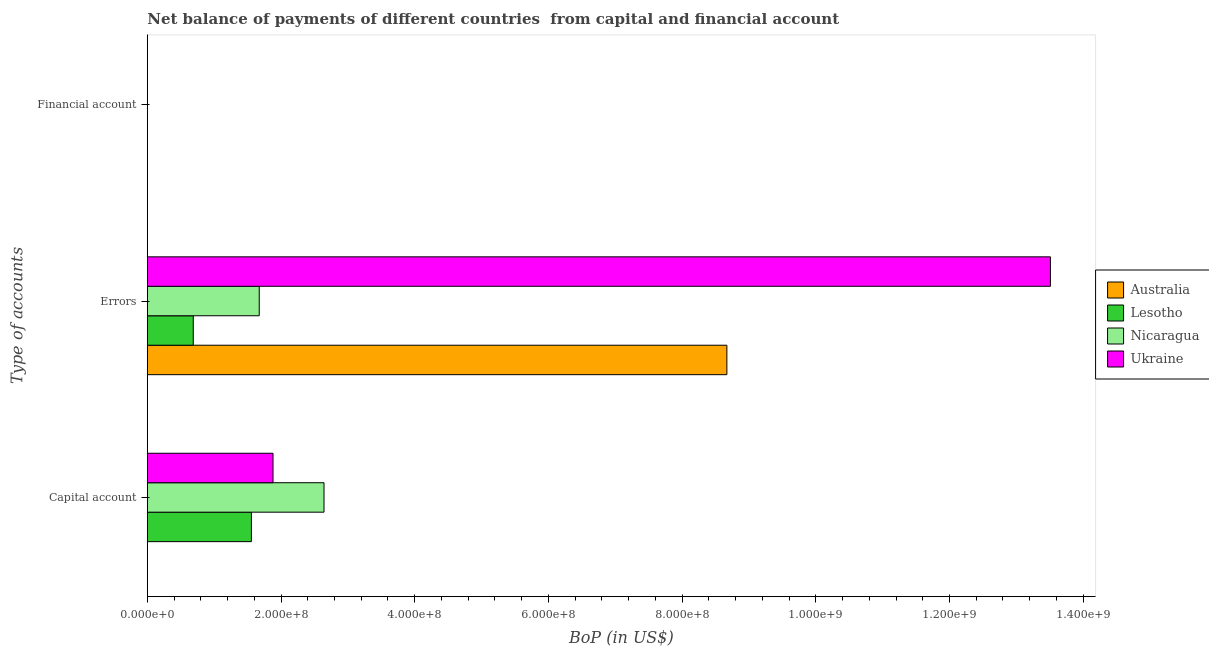Are the number of bars per tick equal to the number of legend labels?
Provide a short and direct response. No. Are the number of bars on each tick of the Y-axis equal?
Give a very brief answer. No. What is the label of the 3rd group of bars from the top?
Offer a terse response. Capital account. What is the amount of errors in Ukraine?
Provide a succinct answer. 1.35e+09. Across all countries, what is the maximum amount of errors?
Provide a succinct answer. 1.35e+09. Across all countries, what is the minimum amount of net capital account?
Your answer should be compact. 0. In which country was the amount of net capital account maximum?
Your answer should be very brief. Nicaragua. What is the total amount of financial account in the graph?
Your response must be concise. 0. What is the difference between the amount of errors in Australia and that in Lesotho?
Your answer should be very brief. 7.98e+08. What is the difference between the amount of errors in Australia and the amount of net capital account in Ukraine?
Provide a succinct answer. 6.79e+08. What is the average amount of errors per country?
Your answer should be very brief. 6.14e+08. What is the difference between the amount of errors and amount of net capital account in Lesotho?
Make the answer very short. -8.70e+07. In how many countries, is the amount of net capital account greater than 1280000000 US$?
Ensure brevity in your answer.  0. What is the ratio of the amount of errors in Australia to that in Ukraine?
Your answer should be very brief. 0.64. What is the difference between the highest and the second highest amount of errors?
Ensure brevity in your answer.  4.84e+08. What is the difference between the highest and the lowest amount of errors?
Ensure brevity in your answer.  1.28e+09. In how many countries, is the amount of financial account greater than the average amount of financial account taken over all countries?
Make the answer very short. 0. Is it the case that in every country, the sum of the amount of net capital account and amount of errors is greater than the amount of financial account?
Make the answer very short. Yes. How many bars are there?
Provide a succinct answer. 7. What is the difference between two consecutive major ticks on the X-axis?
Keep it short and to the point. 2.00e+08. Are the values on the major ticks of X-axis written in scientific E-notation?
Your response must be concise. Yes. Does the graph contain any zero values?
Your answer should be compact. Yes. Where does the legend appear in the graph?
Make the answer very short. Center right. How many legend labels are there?
Provide a short and direct response. 4. How are the legend labels stacked?
Provide a succinct answer. Vertical. What is the title of the graph?
Your answer should be compact. Net balance of payments of different countries  from capital and financial account. What is the label or title of the X-axis?
Make the answer very short. BoP (in US$). What is the label or title of the Y-axis?
Provide a succinct answer. Type of accounts. What is the BoP (in US$) in Lesotho in Capital account?
Ensure brevity in your answer.  1.56e+08. What is the BoP (in US$) in Nicaragua in Capital account?
Your response must be concise. 2.64e+08. What is the BoP (in US$) of Ukraine in Capital account?
Your answer should be compact. 1.88e+08. What is the BoP (in US$) in Australia in Errors?
Your answer should be very brief. 8.67e+08. What is the BoP (in US$) in Lesotho in Errors?
Offer a terse response. 6.87e+07. What is the BoP (in US$) of Nicaragua in Errors?
Make the answer very short. 1.67e+08. What is the BoP (in US$) in Ukraine in Errors?
Ensure brevity in your answer.  1.35e+09. What is the BoP (in US$) in Australia in Financial account?
Provide a succinct answer. 0. What is the BoP (in US$) of Lesotho in Financial account?
Offer a very short reply. 0. What is the BoP (in US$) of Ukraine in Financial account?
Keep it short and to the point. 0. Across all Type of accounts, what is the maximum BoP (in US$) of Australia?
Provide a short and direct response. 8.67e+08. Across all Type of accounts, what is the maximum BoP (in US$) of Lesotho?
Provide a short and direct response. 1.56e+08. Across all Type of accounts, what is the maximum BoP (in US$) in Nicaragua?
Keep it short and to the point. 2.64e+08. Across all Type of accounts, what is the maximum BoP (in US$) of Ukraine?
Your answer should be very brief. 1.35e+09. Across all Type of accounts, what is the minimum BoP (in US$) in Lesotho?
Your response must be concise. 0. Across all Type of accounts, what is the minimum BoP (in US$) in Ukraine?
Make the answer very short. 0. What is the total BoP (in US$) of Australia in the graph?
Provide a short and direct response. 8.67e+08. What is the total BoP (in US$) of Lesotho in the graph?
Your answer should be very brief. 2.24e+08. What is the total BoP (in US$) in Nicaragua in the graph?
Your answer should be compact. 4.32e+08. What is the total BoP (in US$) in Ukraine in the graph?
Offer a very short reply. 1.54e+09. What is the difference between the BoP (in US$) of Lesotho in Capital account and that in Errors?
Give a very brief answer. 8.70e+07. What is the difference between the BoP (in US$) in Nicaragua in Capital account and that in Errors?
Your answer should be compact. 9.69e+07. What is the difference between the BoP (in US$) in Ukraine in Capital account and that in Errors?
Provide a short and direct response. -1.16e+09. What is the difference between the BoP (in US$) of Lesotho in Capital account and the BoP (in US$) of Nicaragua in Errors?
Provide a short and direct response. -1.17e+07. What is the difference between the BoP (in US$) in Lesotho in Capital account and the BoP (in US$) in Ukraine in Errors?
Offer a very short reply. -1.20e+09. What is the difference between the BoP (in US$) in Nicaragua in Capital account and the BoP (in US$) in Ukraine in Errors?
Your answer should be compact. -1.09e+09. What is the average BoP (in US$) in Australia per Type of accounts?
Ensure brevity in your answer.  2.89e+08. What is the average BoP (in US$) of Lesotho per Type of accounts?
Ensure brevity in your answer.  7.48e+07. What is the average BoP (in US$) in Nicaragua per Type of accounts?
Provide a short and direct response. 1.44e+08. What is the average BoP (in US$) in Ukraine per Type of accounts?
Offer a very short reply. 5.13e+08. What is the difference between the BoP (in US$) in Lesotho and BoP (in US$) in Nicaragua in Capital account?
Your response must be concise. -1.09e+08. What is the difference between the BoP (in US$) in Lesotho and BoP (in US$) in Ukraine in Capital account?
Keep it short and to the point. -3.23e+07. What is the difference between the BoP (in US$) of Nicaragua and BoP (in US$) of Ukraine in Capital account?
Provide a short and direct response. 7.63e+07. What is the difference between the BoP (in US$) in Australia and BoP (in US$) in Lesotho in Errors?
Your answer should be very brief. 7.98e+08. What is the difference between the BoP (in US$) of Australia and BoP (in US$) of Nicaragua in Errors?
Offer a terse response. 7.00e+08. What is the difference between the BoP (in US$) of Australia and BoP (in US$) of Ukraine in Errors?
Keep it short and to the point. -4.84e+08. What is the difference between the BoP (in US$) of Lesotho and BoP (in US$) of Nicaragua in Errors?
Your answer should be very brief. -9.87e+07. What is the difference between the BoP (in US$) of Lesotho and BoP (in US$) of Ukraine in Errors?
Give a very brief answer. -1.28e+09. What is the difference between the BoP (in US$) in Nicaragua and BoP (in US$) in Ukraine in Errors?
Provide a succinct answer. -1.18e+09. What is the ratio of the BoP (in US$) of Lesotho in Capital account to that in Errors?
Give a very brief answer. 2.27. What is the ratio of the BoP (in US$) of Nicaragua in Capital account to that in Errors?
Keep it short and to the point. 1.58. What is the ratio of the BoP (in US$) of Ukraine in Capital account to that in Errors?
Make the answer very short. 0.14. What is the difference between the highest and the lowest BoP (in US$) in Australia?
Your response must be concise. 8.67e+08. What is the difference between the highest and the lowest BoP (in US$) in Lesotho?
Offer a very short reply. 1.56e+08. What is the difference between the highest and the lowest BoP (in US$) in Nicaragua?
Provide a short and direct response. 2.64e+08. What is the difference between the highest and the lowest BoP (in US$) of Ukraine?
Provide a short and direct response. 1.35e+09. 